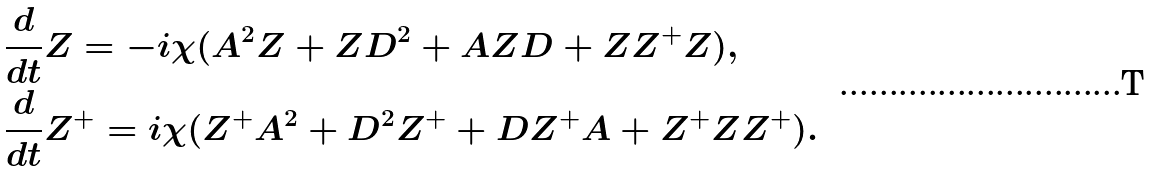<formula> <loc_0><loc_0><loc_500><loc_500>& \frac { d } { d t } Z = - i \chi ( A ^ { 2 } Z + Z D ^ { 2 } + A Z D + Z Z ^ { + } Z ) , \\ & \frac { d } { d t } Z ^ { + } = i \chi ( Z ^ { + } A ^ { 2 } + D ^ { 2 } Z ^ { + } + D Z ^ { + } A + Z ^ { + } Z Z ^ { + } ) .</formula> 